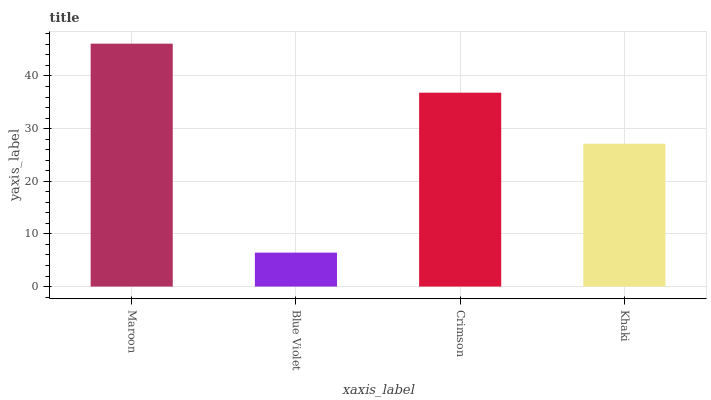Is Blue Violet the minimum?
Answer yes or no. Yes. Is Maroon the maximum?
Answer yes or no. Yes. Is Crimson the minimum?
Answer yes or no. No. Is Crimson the maximum?
Answer yes or no. No. Is Crimson greater than Blue Violet?
Answer yes or no. Yes. Is Blue Violet less than Crimson?
Answer yes or no. Yes. Is Blue Violet greater than Crimson?
Answer yes or no. No. Is Crimson less than Blue Violet?
Answer yes or no. No. Is Crimson the high median?
Answer yes or no. Yes. Is Khaki the low median?
Answer yes or no. Yes. Is Blue Violet the high median?
Answer yes or no. No. Is Blue Violet the low median?
Answer yes or no. No. 